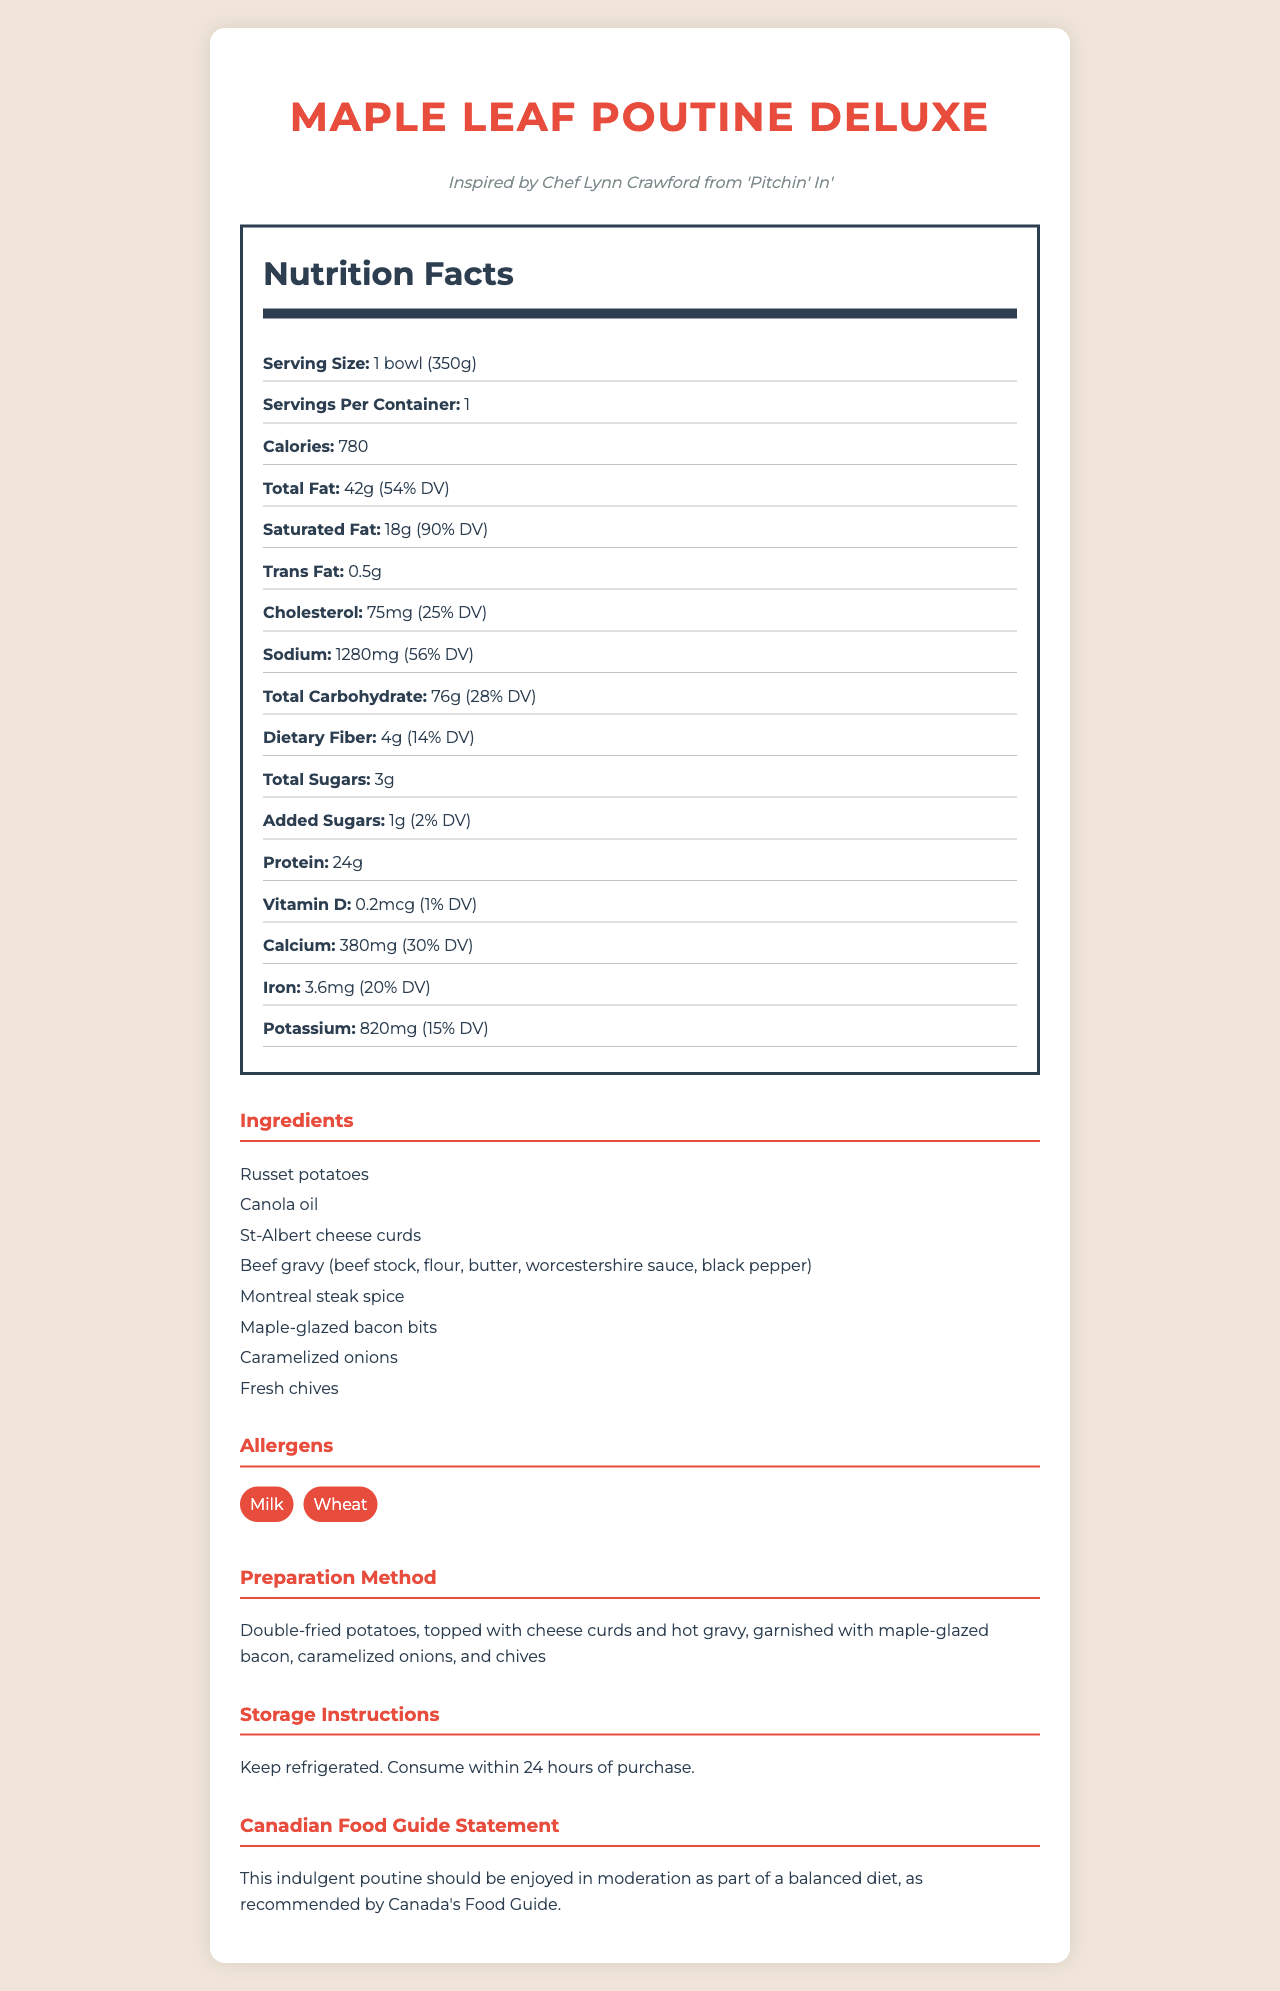what is the serving size of Maple Leaf Poutine Deluxe? The serving size is mentioned in the Nutrition Facts section of the document.
Answer: 1 bowl (350g) how many calories are there per serving? The calories per serving are clearly listed under the Nutrition Facts heading.
Answer: 780 what is the total fat content in grams? The total fat content is provided in the Nutrition Facts section as 42g.
Answer: 42g how much dietary fiber does this product contain? The dietary fiber content is listed as 4g in the Nutrition Facts section.
Answer: 4g what are the main ingredients of Maple Leaf Poutine Deluxe's gravy? These are listed in the ingredients section of the document.
Answer: Beef stock, flour, butter, Worcestershire sauce, black pepper how much sodium does one serving contain? A. 900 mg B. 1280 mg C. 1500 mg D. 2000 mg The sodium content per serving is listed as 1280 mg in the Nutrition Facts section.
Answer: B. 1280 mg which of the following is an allergen in Maple Leaf Poutine Deluxe? I. Nuts II. Milk III. Soy IV. Wheat The allergens section lists Milk and Wheat as present in the product.
Answer: II. Milk and IV. Wheat does this product contain any trans fat? The Nutrition Facts section lists the trans fat content as 0.5g.
Answer: Yes should the Maple Leaf Poutine Deluxe be consumed regularly as a part of a balanced diet? The Canadian Food Guide Statement mentions that this product should be enjoyed in moderation as part of a balanced diet.
Answer: No who is the chef that inspired this poutine recipe? The document mentions that the recipe is inspired by Chef Lynn Crawford from the show 'Pitchin' In'.
Answer: Chef Lynn Crawford from 'Pitchin' In' summarize the document The document covers various aspects of the Maple Leaf Poutine Deluxe, highlighting its nutritional content, ingredients, allergens, preparation method, storage instructions, and a guideline from Canada's Food Guide about its consumption.
Answer: The document provides detailed information about the Maple Leaf Poutine Deluxe, a gourmet poutine inspired by Chef Lynn Crawford. It includes the serving size, nutrition facts, ingredients, allergens, preparation method, storage instructions, and a statement from Canada's Food Guide. This poutine is described as indulgent and should be enjoyed in moderation. what is the exact amount of potassium in Maple Leaf Poutine Deluxe? The Nutrition Facts section lists the potassium content as 820 mg.
Answer: 820 mg is there any added sugar in Maple Leaf Poutine Deluxe? The amount of added sugars is listed as 1g in the Nutrition Facts section.
Answer: Yes how is the Maple Leaf Poutine Deluxe stored? The storage instructions provide clear guidance on how to store the product.
Answer: Keep refrigerated. Consume within 24 hours of purchase. what inspired the preparation method of this poutine? The document does not provide information on what inspired the preparation method, only the final preparation method itself is described.
Answer: Cannot be determined 